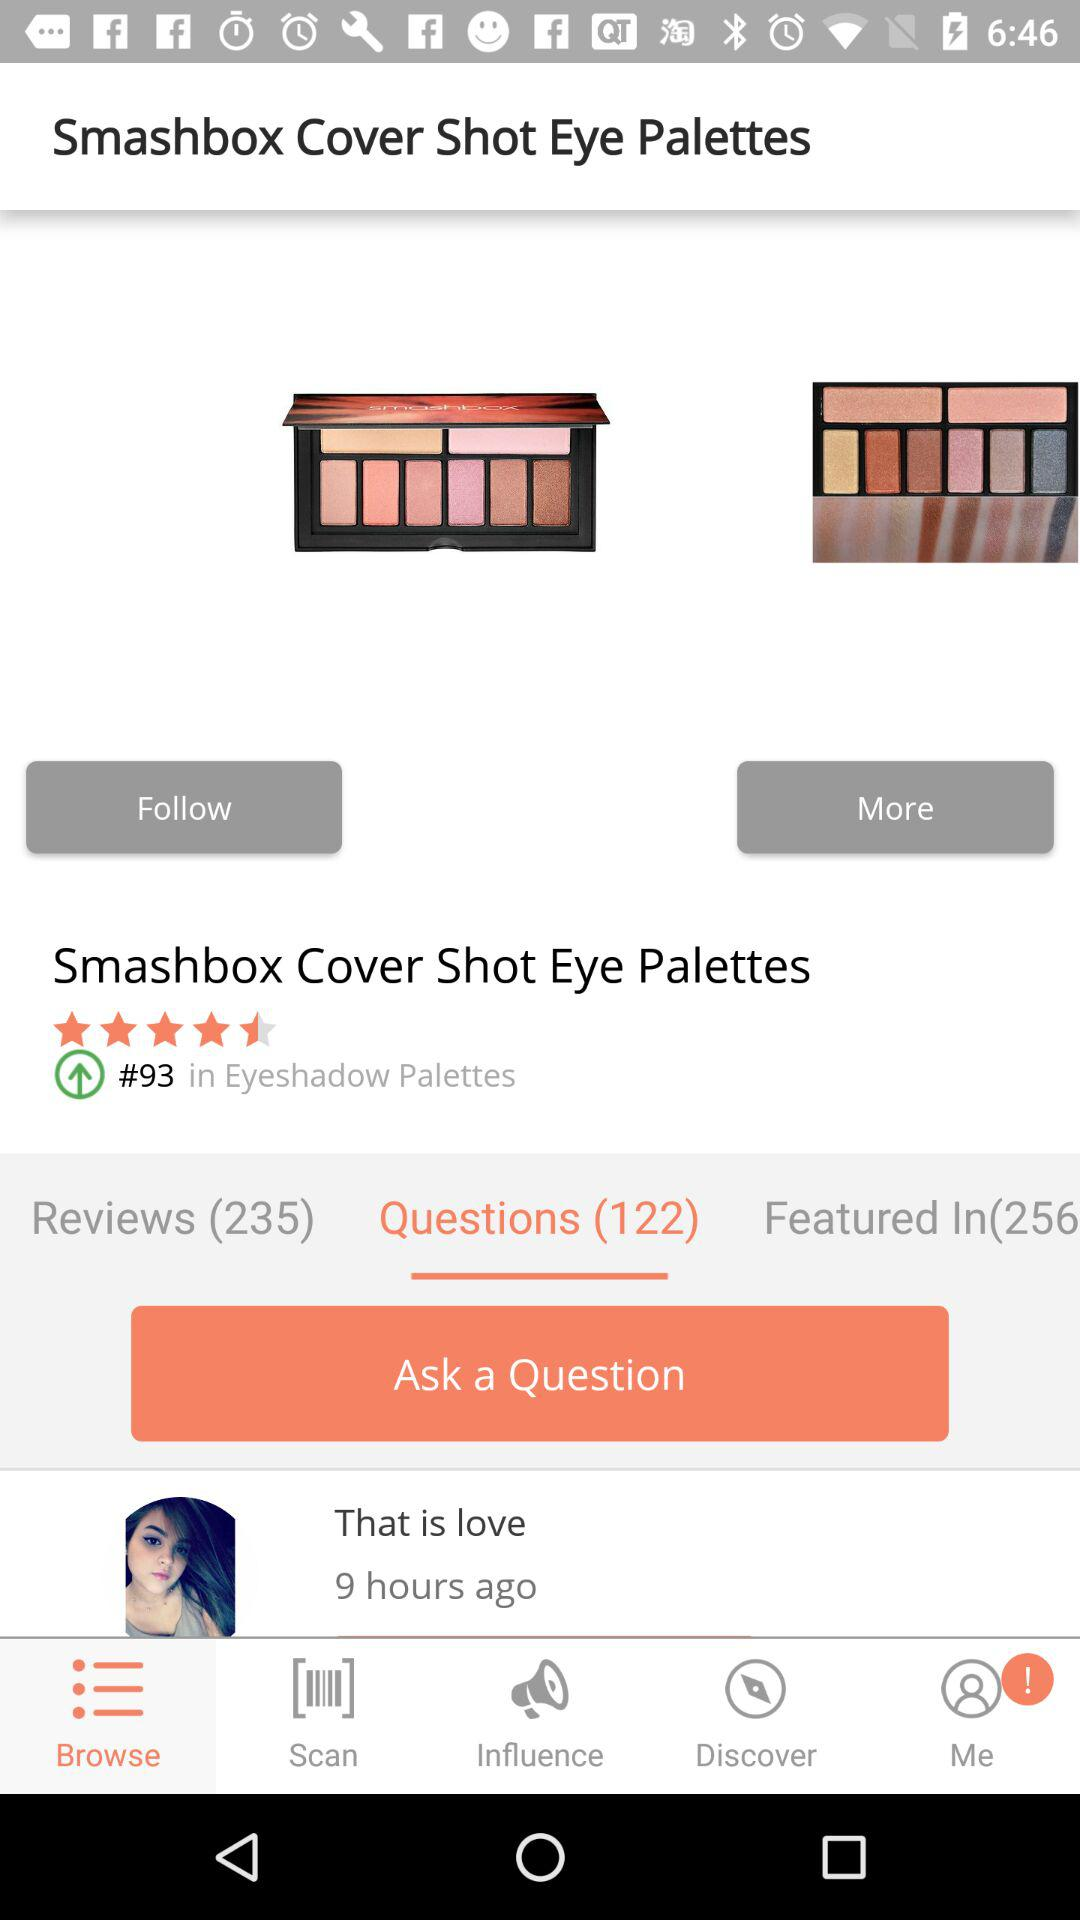How many reviews are there for this product?
Answer the question using a single word or phrase. 235 